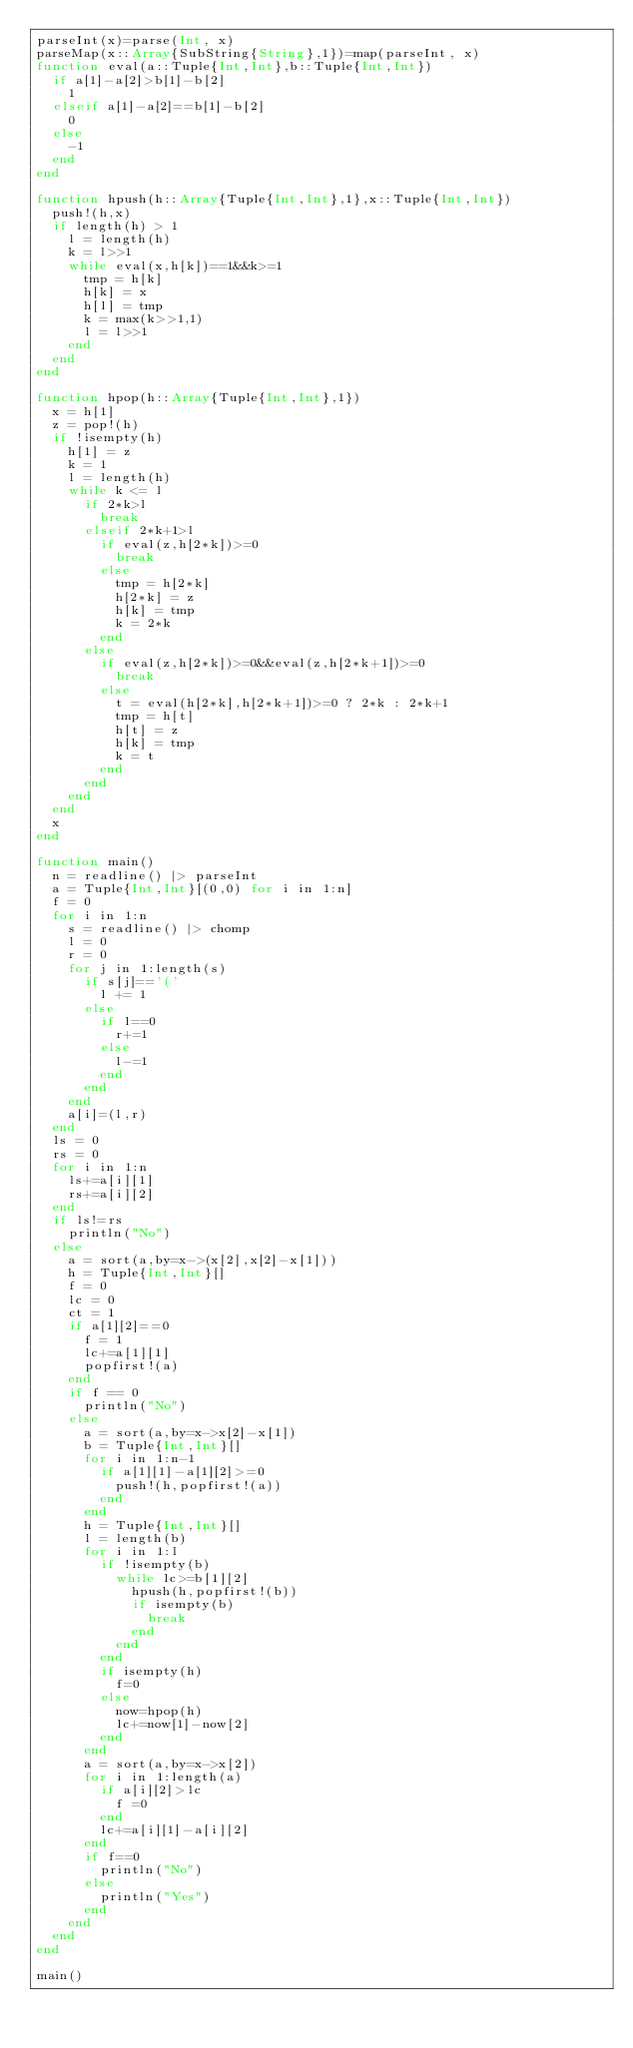Convert code to text. <code><loc_0><loc_0><loc_500><loc_500><_Julia_>parseInt(x)=parse(Int, x)
parseMap(x::Array{SubString{String},1})=map(parseInt, x)
function eval(a::Tuple{Int,Int},b::Tuple{Int,Int})
	if a[1]-a[2]>b[1]-b[2]
		1
	elseif a[1]-a[2]==b[1]-b[2]
		0
	else
		-1
	end
end

function hpush(h::Array{Tuple{Int,Int},1},x::Tuple{Int,Int})
	push!(h,x)
	if length(h) > 1
		l = length(h)
		k = l>>1
		while eval(x,h[k])==1&&k>=1
			tmp = h[k]
			h[k] = x
			h[l] = tmp
			k = max(k>>1,1)
			l = l>>1
		end
	end
end

function hpop(h::Array{Tuple{Int,Int},1})
	x = h[1]
	z = pop!(h)
	if !isempty(h)
		h[1] = z
		k = 1
		l = length(h)
		while k <= l
			if 2*k>l
				break
			elseif 2*k+1>l
				if eval(z,h[2*k])>=0
					break
				else
					tmp = h[2*k]
					h[2*k] = z
					h[k] = tmp
					k = 2*k
				end
			else
				if eval(z,h[2*k])>=0&&eval(z,h[2*k+1])>=0
					break
				else
					t = eval(h[2*k],h[2*k+1])>=0 ? 2*k : 2*k+1
					tmp = h[t]
					h[t] = z
					h[k] = tmp
					k = t
				end
			end
		end
	end
	x
end

function main()
	n = readline() |> parseInt
	a = Tuple{Int,Int}[(0,0) for i in 1:n]
	f = 0
	for i in 1:n
		s = readline() |> chomp
		l = 0
		r = 0
		for j in 1:length(s)
			if s[j]=='('
				l += 1
			else
				if l==0
					r+=1
				else
					l-=1
				end
			end
		end
		a[i]=(l,r)
	end
	ls = 0
	rs = 0
	for i in 1:n
		ls+=a[i][1]
		rs+=a[i][2]
	end
	if ls!=rs
		println("No")
	else
		a = sort(a,by=x->(x[2],x[2]-x[1]))
		h = Tuple{Int,Int}[]
		f = 0
		lc = 0
		ct = 1
		if a[1][2]==0
			f = 1
			lc+=a[1][1]
			popfirst!(a)
		end
		if f == 0
			println("No")
		else
			a = sort(a,by=x->x[2]-x[1])
			b = Tuple{Int,Int}[]
			for i in 1:n-1
				if a[1][1]-a[1][2]>=0
					push!(h,popfirst!(a))
				end
			end
			h = Tuple{Int,Int}[]
			l = length(b)
			for i in 1:l
				if !isempty(b)
					while lc>=b[1][2]
						hpush(h,popfirst!(b))
						if isempty(b)
							break
						end
					end
				end
				if isempty(h)
					f=0
				else
					now=hpop(h)
					lc+=now[1]-now[2]
				end
			end
			a = sort(a,by=x->x[2])
			for i in 1:length(a)
				if a[i][2]>lc
					f =0
				end
				lc+=a[i][1]-a[i][2]
			end
			if f==0
				println("No")
			else
				println("Yes")
			end
		end
	end
end

main()</code> 